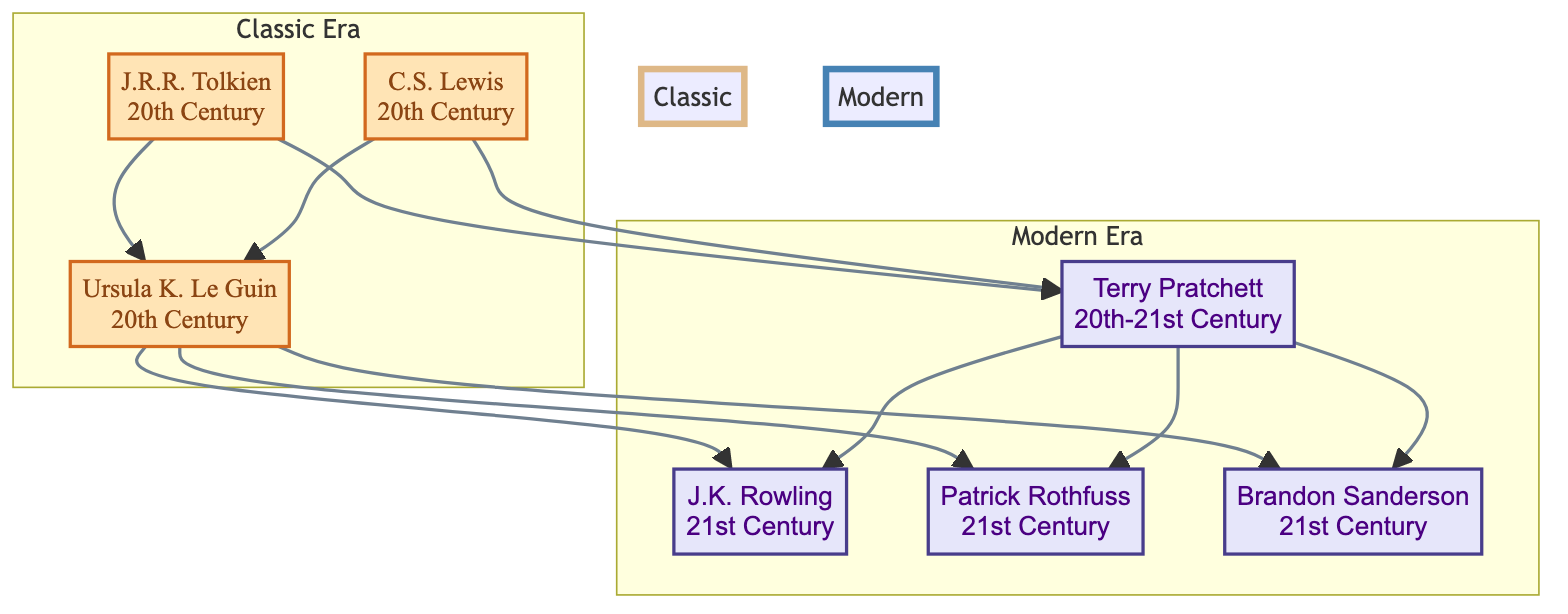What is the era of J.R.R. Tolkien? The diagram explicitly states that J.R.R. Tolkien belongs to the "20th Century" era. This information is directly associated with his node.
Answer: 20th Century Which author contributed to the idea of magical technology in Harry Potter? The diagram indicates that J.K. Rowling is the author associated with the creation of a technological-magical hybrid universe in Harry Potter, as mentioned in her contribution.
Answer: J.K. Rowling How many authors are listed in the Classic Era? By counting the nodes labeled in the "Classic Era" subgraph, we identify three authors: J.R.R. Tolkien, C.S. Lewis, and Ursula K. Le Guin.
Answer: 3 Who are the authors related to Ursula K. Le Guin? The diagram shows that both C.S. Lewis and J.K. Rowling are directly linked to Ursula K. Le Guin through edges. This indicates that those authors followed her influence.
Answer: C.S. Lewis and J.K. Rowling What type of themes did Terry Pratchett satirize in his works? The contribution mentioned for Terry Pratchett states that he satirized "modern life," indicating the themes he focused on in his writing.
Answer: Modern life Which author is known for detailed magic systems akin to scientific principles? The diagram notes that Brandon Sanderson is specifically recognized for his magic systems that function like scientific principles, making him the author known for this concept.
Answer: Brandon Sanderson How many connections does Patrick Rothfuss have in the family tree? Patrick Rothfuss has three direct connections in the diagram, which include links to Ursula K. Le Guin, Terry Pratchett, and J.K. Rowling. By visual counting, this confirms his connections.
Answer: 3 Which author is linked to both J.R.R. Tolkien and Terry Pratchett through intermediate relationships? Following the lineage in the diagram, Ursula K. Le Guin is connected back to J.R.R. Tolkien and forwards to Terry Pratchett, demonstrating her intermediate relationship.
Answer: Ursula K. Le Guin What commonality exists between C.S. Lewis and Ursula K. Le Guin's contributions? The contributions of both authors emphasize exploring deeper societal themes – C.S. Lewis with moral philosophy and Ursula K. Le Guin with sociopolitical issues, showcasing their thematic overlap.
Answer: Deeper societal themes 